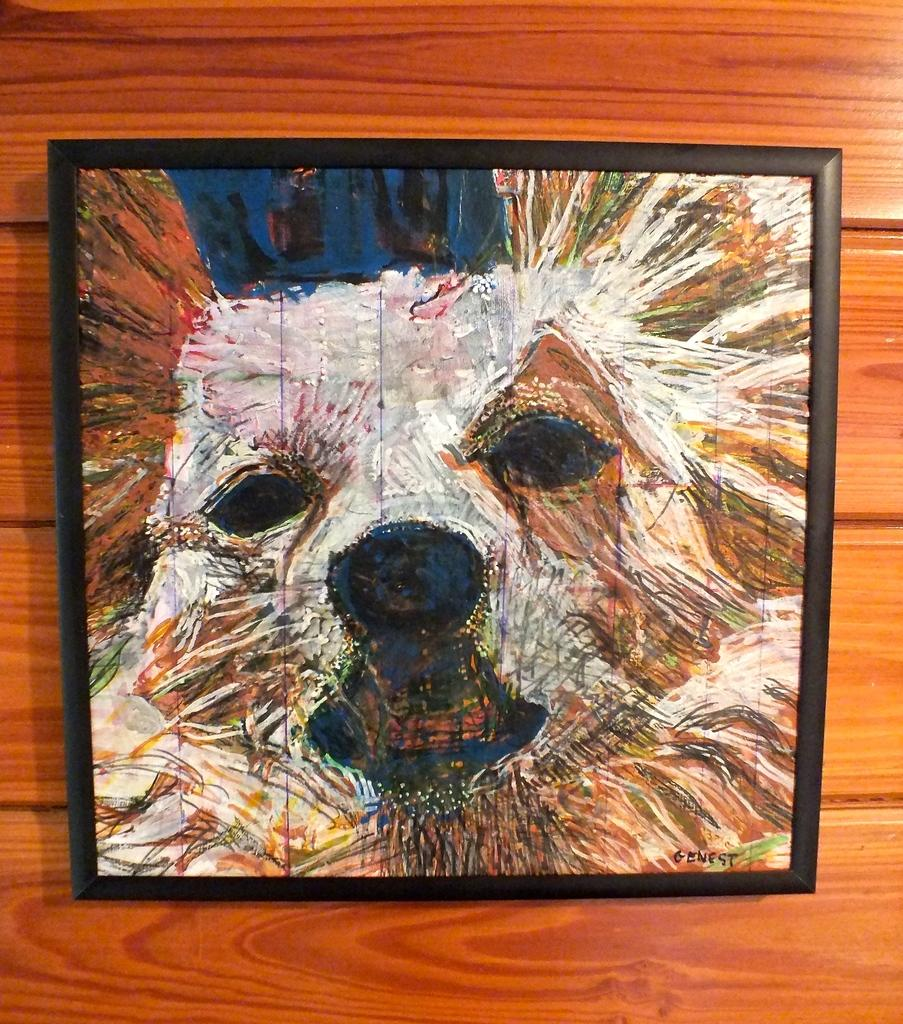What is depicted in the painting in the image? There is a dog painting in the image. How is the dog painting displayed? The dog painting is framed. What can be said about the frame's appearance? The frame is colorful. Where is the framed dog painting attached? The framed dog painting is attached to a wooden wall. What direction does the dog painting face in the image? The provided facts do not mention the direction the dog painting faces, so it cannot be determined from the image. 